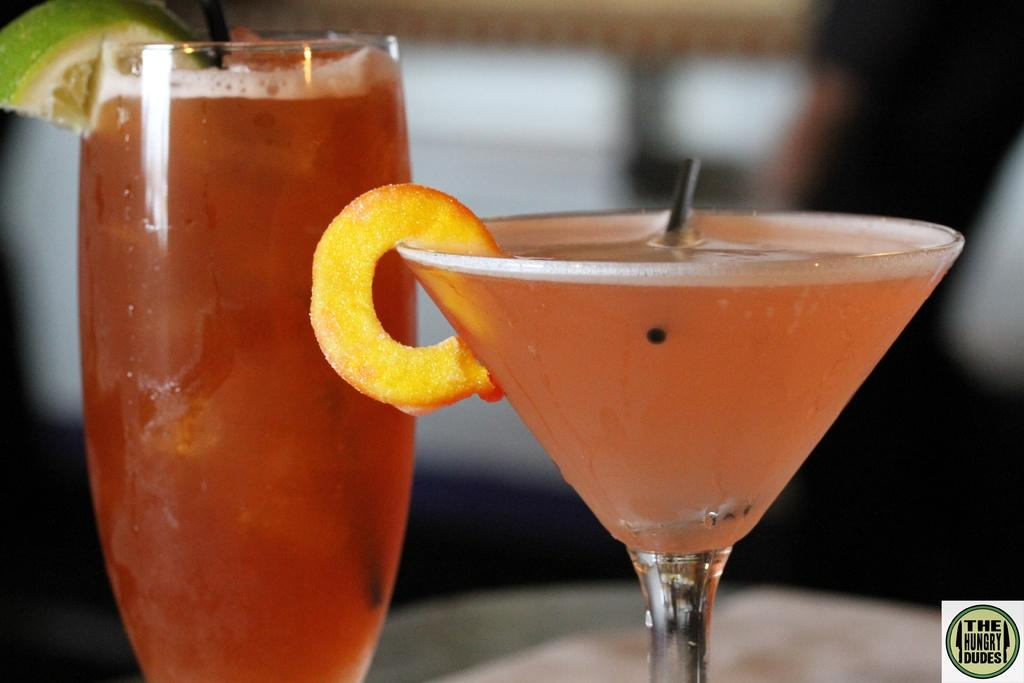How many glasses can be seen in the image? There are two different glasses in the image. What are the glasses filled with? The glasses are filled with cool drinks. Where are the glasses located? The glasses are present on a table. What day of the week is represented by the glasses in the image? The image does not depict a specific day of the week, and there is no indication that the glasses represent a particular day. 